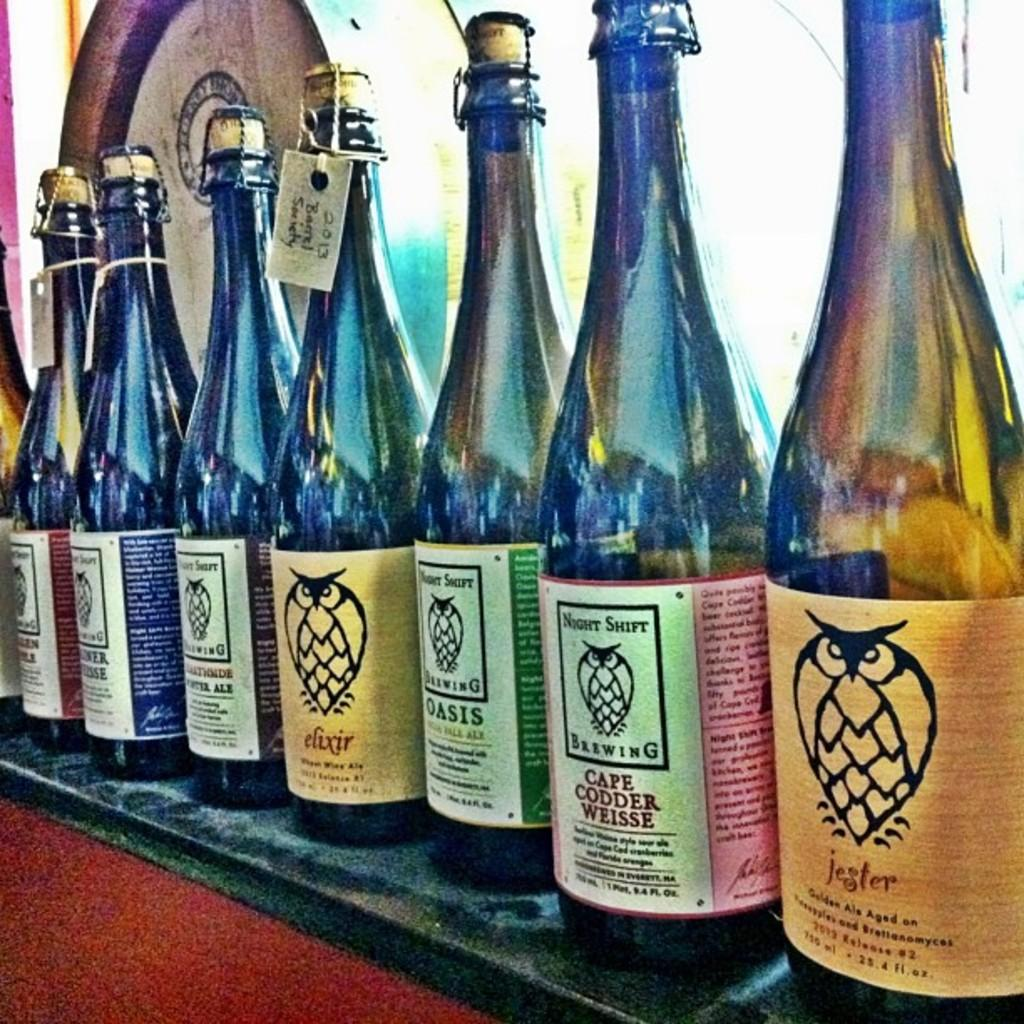<image>
Describe the image concisely. Night Shift Brewing has a label with an owl on it. 